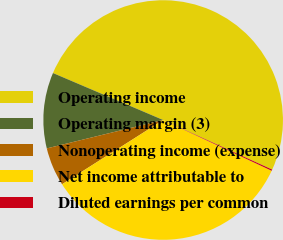<chart> <loc_0><loc_0><loc_500><loc_500><pie_chart><fcel>Operating income<fcel>Operating margin (3)<fcel>Nonoperating income (expense)<fcel>Net income attributable to<fcel>Diluted earnings per common<nl><fcel>50.38%<fcel>10.22%<fcel>5.2%<fcel>34.03%<fcel>0.17%<nl></chart> 